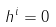<formula> <loc_0><loc_0><loc_500><loc_500>h ^ { i } = 0</formula> 